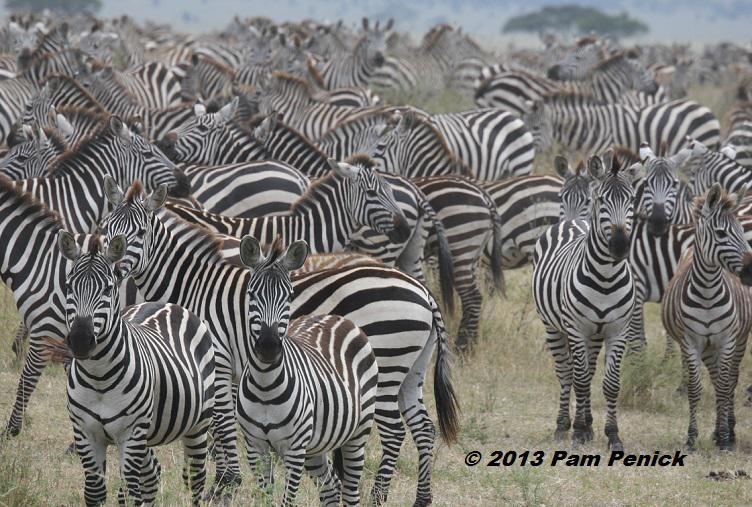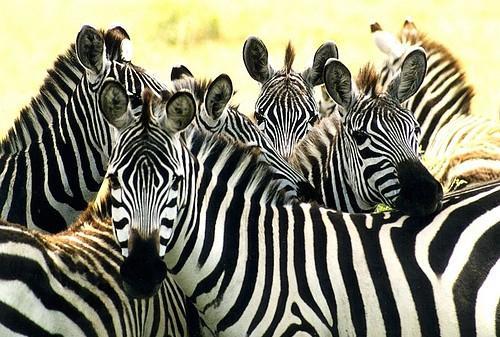The first image is the image on the left, the second image is the image on the right. Evaluate the accuracy of this statement regarding the images: "There are zebras drinking water.". Is it true? Answer yes or no. No. The first image is the image on the left, the second image is the image on the right. Given the left and right images, does the statement "An image shows a row of zebras with the adult zebras bending their necks to the water as they stand in water." hold true? Answer yes or no. No. 